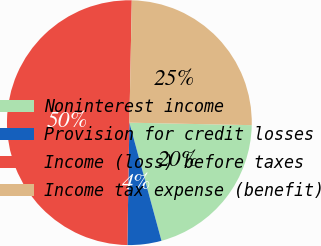<chart> <loc_0><loc_0><loc_500><loc_500><pie_chart><fcel>Noninterest income<fcel>Provision for credit losses<fcel>Income (loss) before taxes<fcel>Income tax expense (benefit)<nl><fcel>20.45%<fcel>4.49%<fcel>50.05%<fcel>25.01%<nl></chart> 